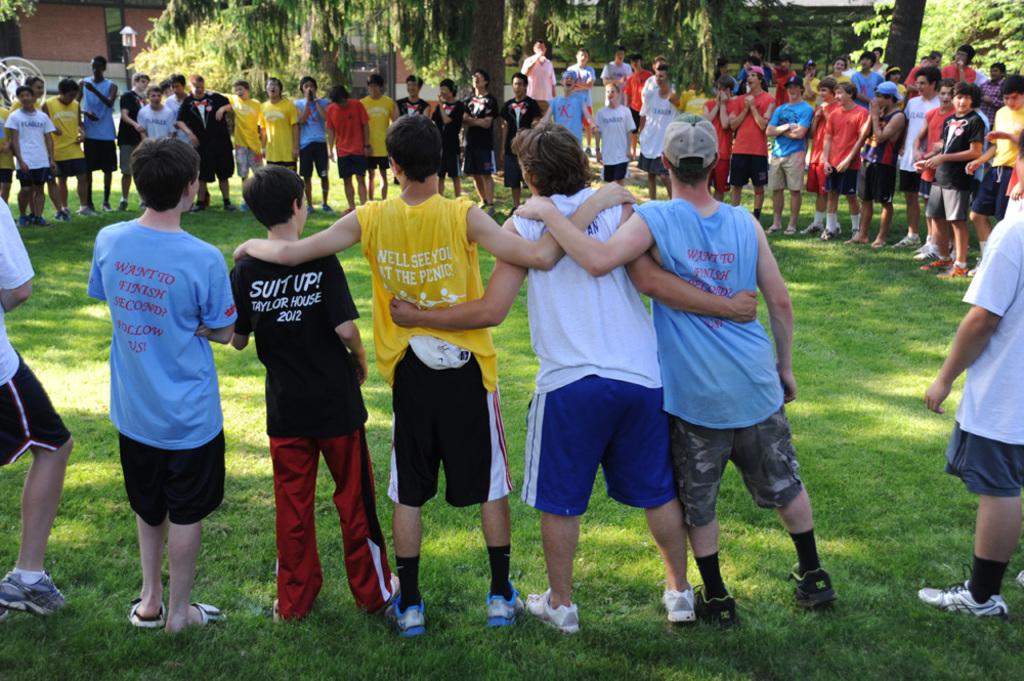What does the black shirt say?
Give a very brief answer. Suit up. 